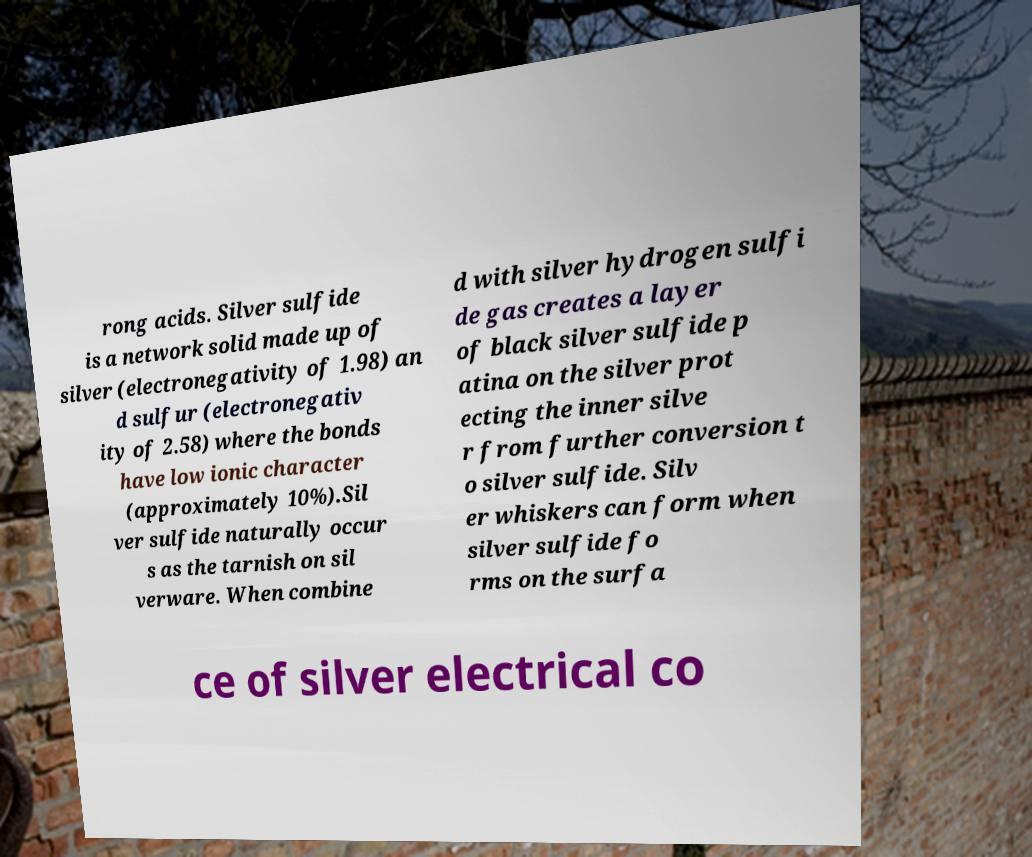There's text embedded in this image that I need extracted. Can you transcribe it verbatim? rong acids. Silver sulfide is a network solid made up of silver (electronegativity of 1.98) an d sulfur (electronegativ ity of 2.58) where the bonds have low ionic character (approximately 10%).Sil ver sulfide naturally occur s as the tarnish on sil verware. When combine d with silver hydrogen sulfi de gas creates a layer of black silver sulfide p atina on the silver prot ecting the inner silve r from further conversion t o silver sulfide. Silv er whiskers can form when silver sulfide fo rms on the surfa ce of silver electrical co 